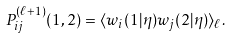<formula> <loc_0><loc_0><loc_500><loc_500>P _ { i j } ^ { ( \ell + 1 ) } ( 1 , 2 ) = \langle w _ { i } ( 1 | \eta ) w _ { j } ( 2 | \eta ) \rangle _ { \ell } .</formula> 